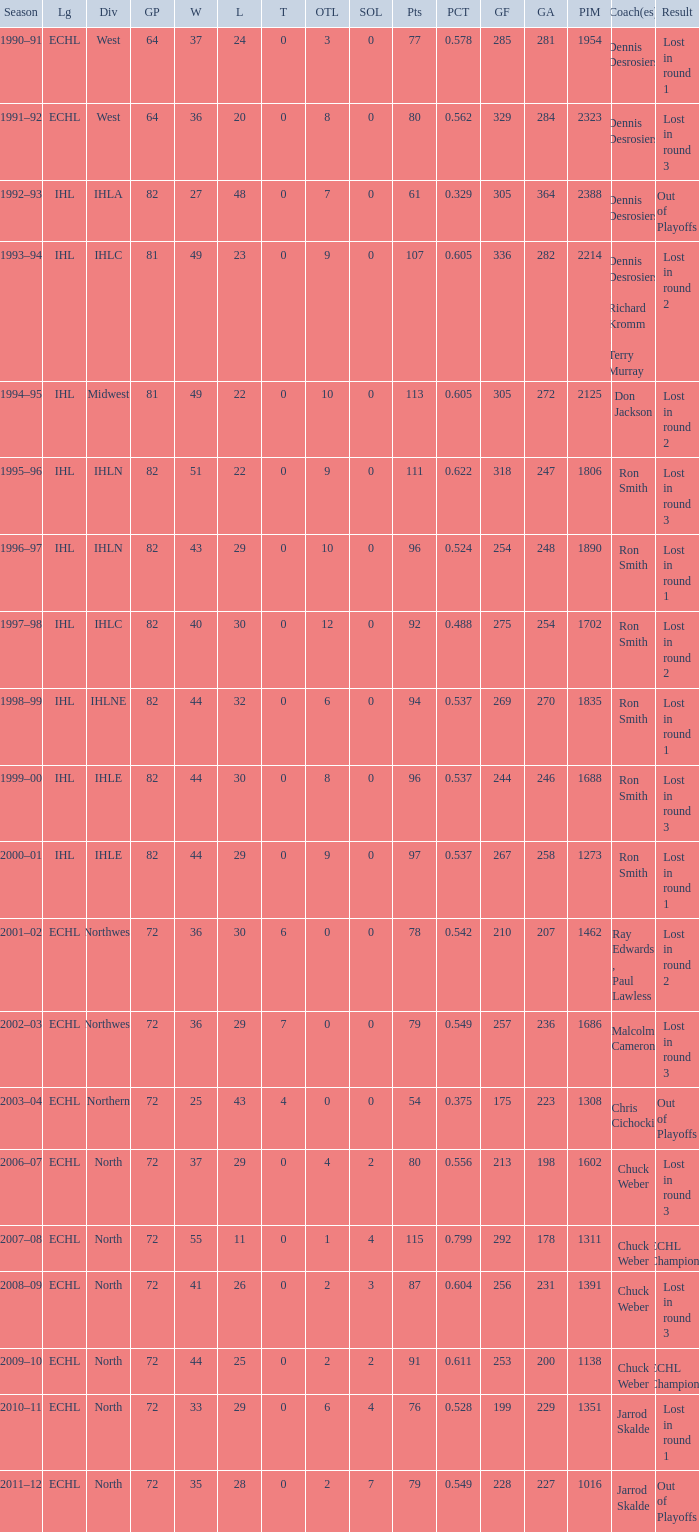How many season did the team lost in round 1 with a GP of 64? 1.0. 